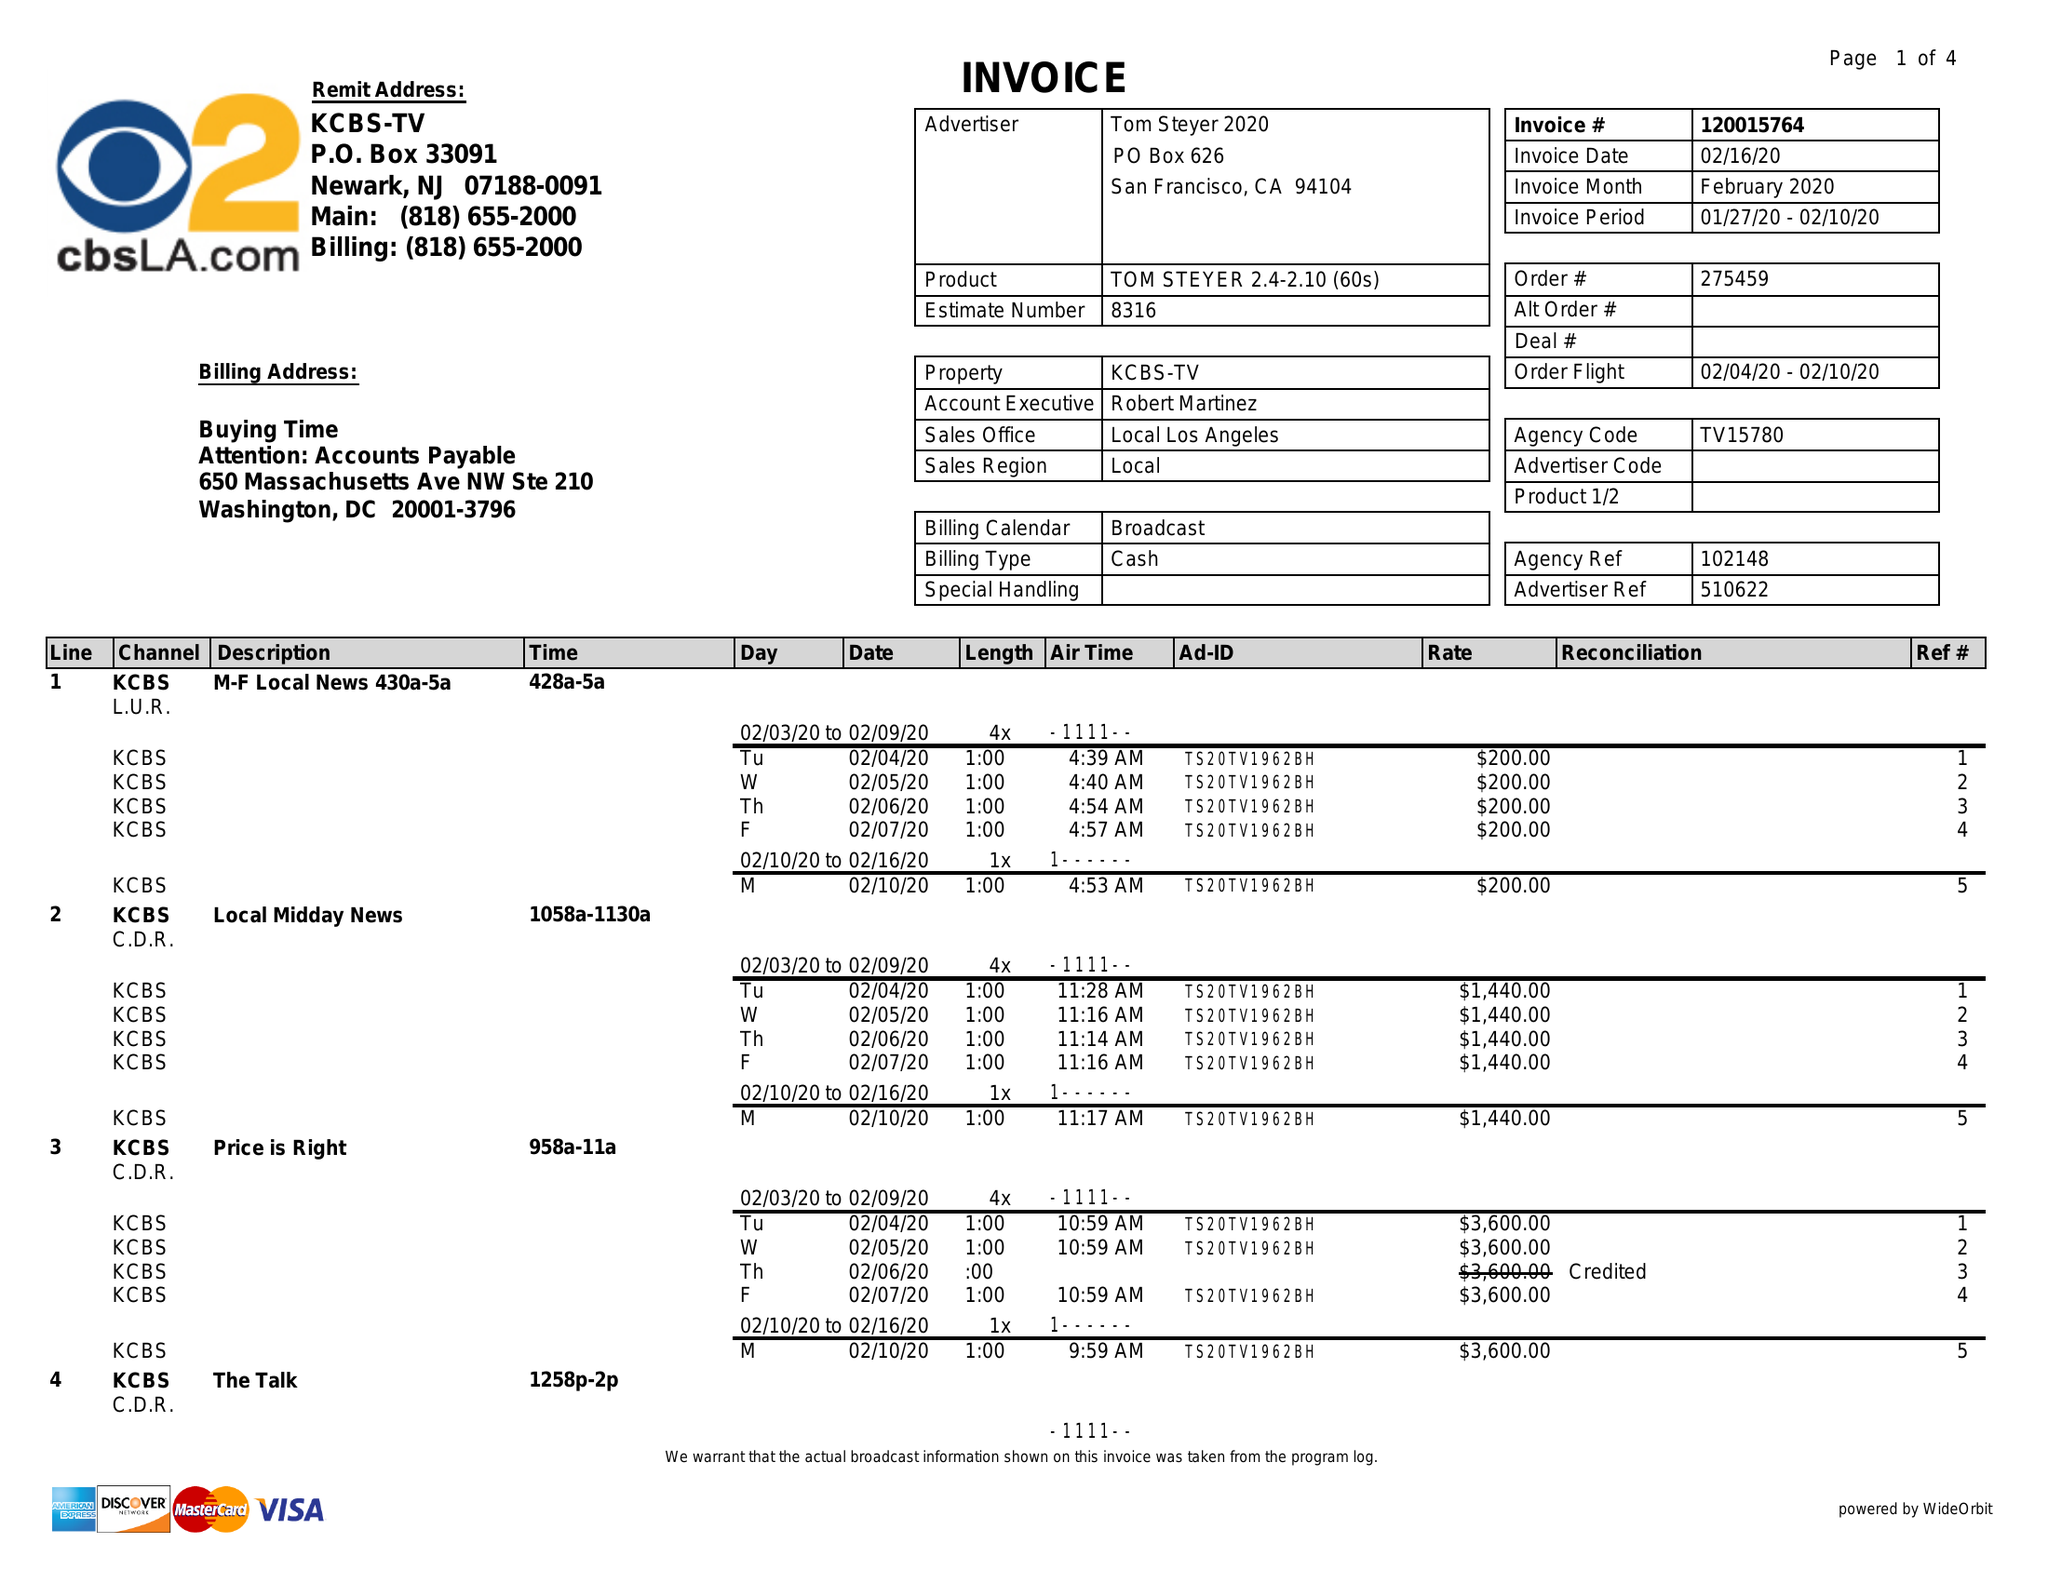What is the value for the flight_to?
Answer the question using a single word or phrase. 02/10/20 